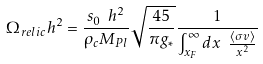Convert formula to latex. <formula><loc_0><loc_0><loc_500><loc_500>\Omega _ { r e l i c } h ^ { 2 } = \frac { s _ { 0 } \ h ^ { 2 } } { \rho _ { c } M _ { P l } } \sqrt { \frac { 4 5 } { \pi g _ { * } } } \frac { 1 } { \int _ { x _ { F } } ^ { \infty } d x \ \frac { \langle \sigma v \rangle } { x ^ { 2 } } }</formula> 